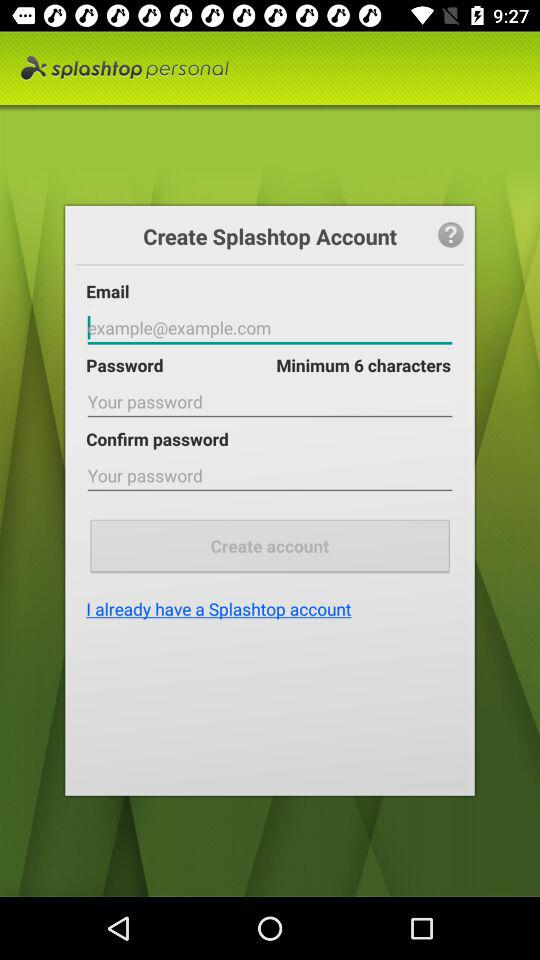How many minimum characters are required for a password? The minimum number of characters required for a password is 6. 